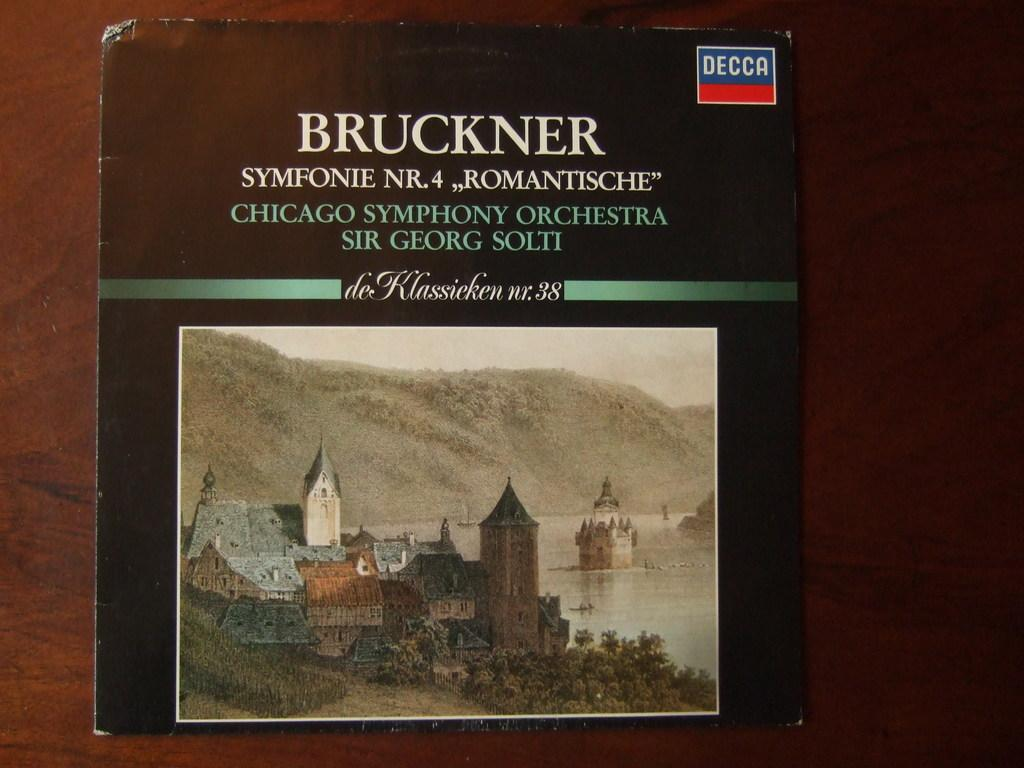<image>
Relay a brief, clear account of the picture shown. A LP record of Bruckner Symfonie Nr 4 played by the Chicago Symphony Orchestra laying on top of a wood table top. 